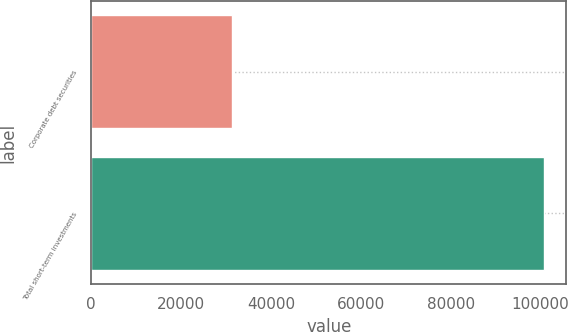Convert chart to OTSL. <chart><loc_0><loc_0><loc_500><loc_500><bar_chart><fcel>Corporate debt securities<fcel>Total short-term investments<nl><fcel>31359<fcel>100704<nl></chart> 